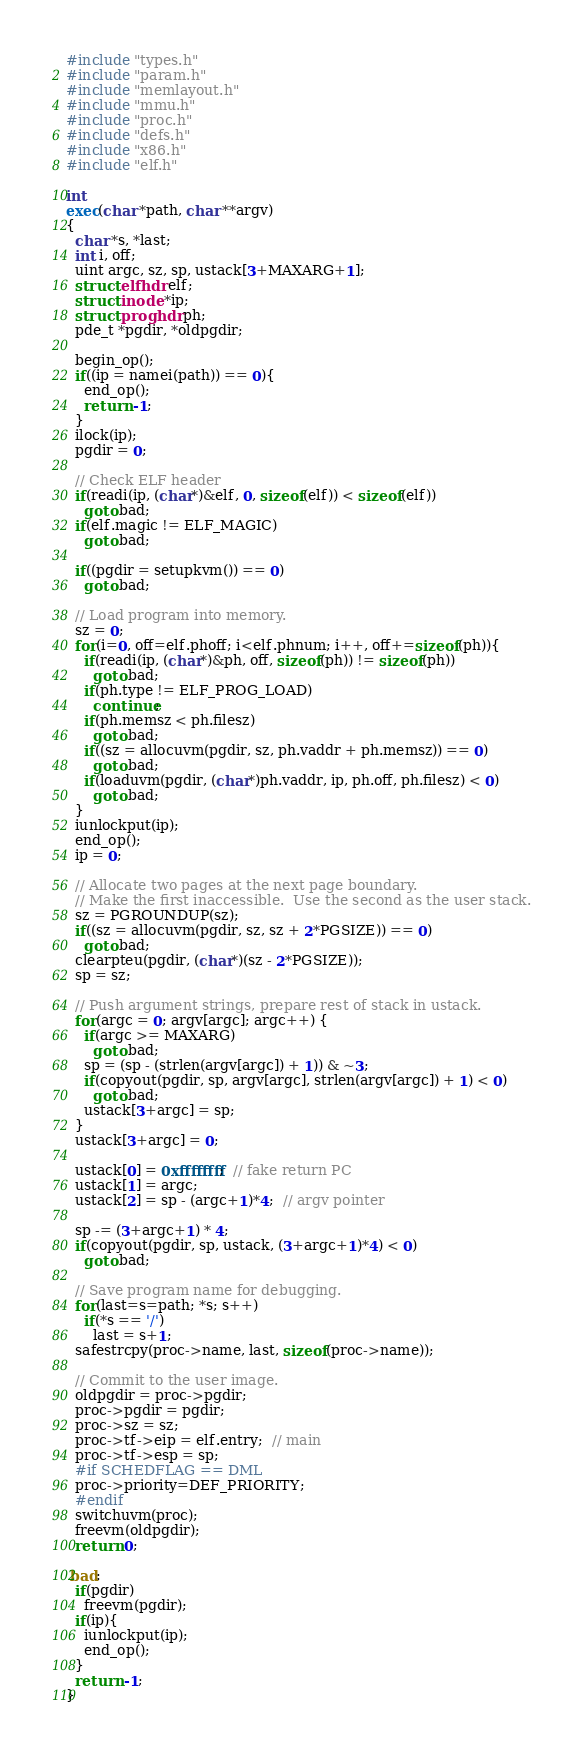<code> <loc_0><loc_0><loc_500><loc_500><_C_>#include "types.h"
#include "param.h"
#include "memlayout.h"
#include "mmu.h"
#include "proc.h"
#include "defs.h"
#include "x86.h"
#include "elf.h"

int
exec(char *path, char **argv)
{
  char *s, *last;
  int i, off;
  uint argc, sz, sp, ustack[3+MAXARG+1];
  struct elfhdr elf;
  struct inode *ip;
  struct proghdr ph;
  pde_t *pgdir, *oldpgdir;

  begin_op();
  if((ip = namei(path)) == 0){
    end_op();
    return -1;
  }
  ilock(ip);
  pgdir = 0;

  // Check ELF header
  if(readi(ip, (char*)&elf, 0, sizeof(elf)) < sizeof(elf))
    goto bad;
  if(elf.magic != ELF_MAGIC)
    goto bad;

  if((pgdir = setupkvm()) == 0)
    goto bad;

  // Load program into memory.
  sz = 0;
  for(i=0, off=elf.phoff; i<elf.phnum; i++, off+=sizeof(ph)){
    if(readi(ip, (char*)&ph, off, sizeof(ph)) != sizeof(ph))
      goto bad;
    if(ph.type != ELF_PROG_LOAD)
      continue;
    if(ph.memsz < ph.filesz)
      goto bad;
    if((sz = allocuvm(pgdir, sz, ph.vaddr + ph.memsz)) == 0)
      goto bad;
    if(loaduvm(pgdir, (char*)ph.vaddr, ip, ph.off, ph.filesz) < 0)
      goto bad;
  }
  iunlockput(ip);
  end_op();
  ip = 0;

  // Allocate two pages at the next page boundary.
  // Make the first inaccessible.  Use the second as the user stack.
  sz = PGROUNDUP(sz);
  if((sz = allocuvm(pgdir, sz, sz + 2*PGSIZE)) == 0)
    goto bad;
  clearpteu(pgdir, (char*)(sz - 2*PGSIZE));
  sp = sz;

  // Push argument strings, prepare rest of stack in ustack.
  for(argc = 0; argv[argc]; argc++) {
    if(argc >= MAXARG)
      goto bad;
    sp = (sp - (strlen(argv[argc]) + 1)) & ~3;
    if(copyout(pgdir, sp, argv[argc], strlen(argv[argc]) + 1) < 0)
      goto bad;
    ustack[3+argc] = sp;
  }
  ustack[3+argc] = 0;

  ustack[0] = 0xffffffff;  // fake return PC
  ustack[1] = argc;
  ustack[2] = sp - (argc+1)*4;  // argv pointer

  sp -= (3+argc+1) * 4;
  if(copyout(pgdir, sp, ustack, (3+argc+1)*4) < 0)
    goto bad;

  // Save program name for debugging.
  for(last=s=path; *s; s++)
    if(*s == '/')
      last = s+1;
  safestrcpy(proc->name, last, sizeof(proc->name));

  // Commit to the user image.
  oldpgdir = proc->pgdir;
  proc->pgdir = pgdir;
  proc->sz = sz;
  proc->tf->eip = elf.entry;  // main
  proc->tf->esp = sp;
  #if SCHEDFLAG == DML
  proc->priority=DEF_PRIORITY;
  #endif
  switchuvm(proc);
  freevm(oldpgdir);
  return 0;

 bad:
  if(pgdir)
    freevm(pgdir);
  if(ip){
    iunlockput(ip);
    end_op();
  }
  return -1;
}
</code> 